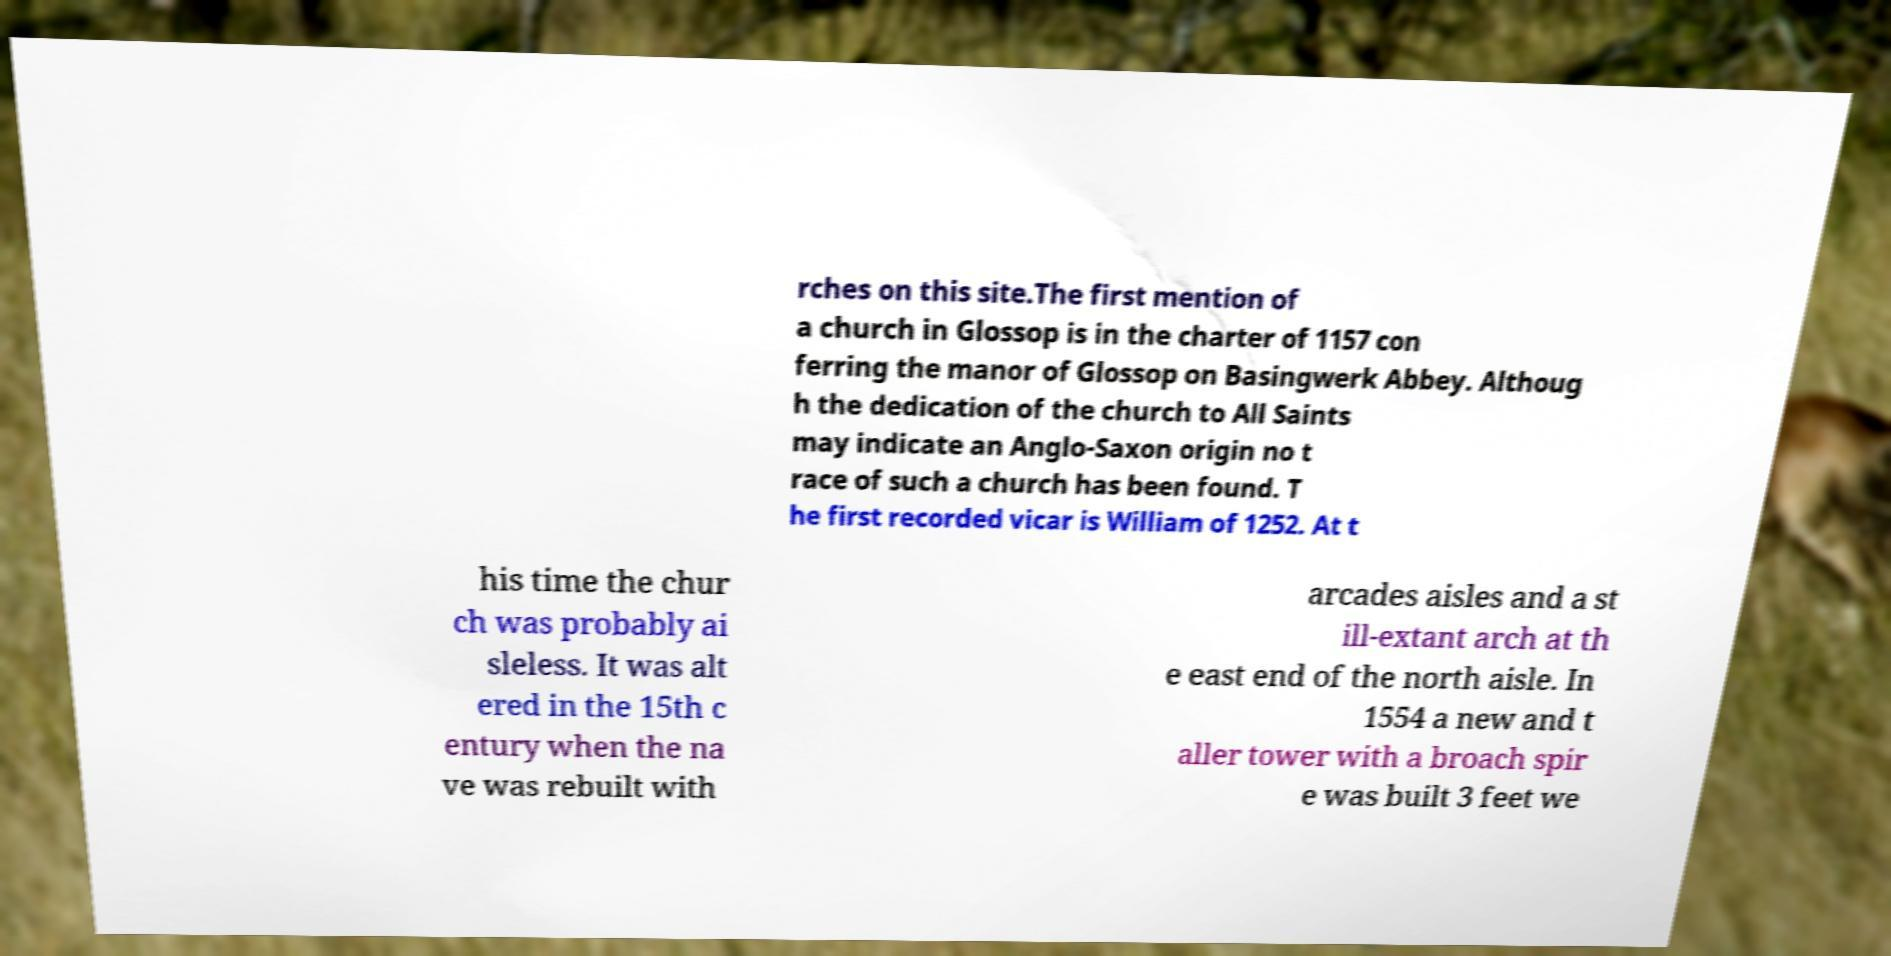Could you assist in decoding the text presented in this image and type it out clearly? rches on this site.The first mention of a church in Glossop is in the charter of 1157 con ferring the manor of Glossop on Basingwerk Abbey. Althoug h the dedication of the church to All Saints may indicate an Anglo-Saxon origin no t race of such a church has been found. T he first recorded vicar is William of 1252. At t his time the chur ch was probably ai sleless. It was alt ered in the 15th c entury when the na ve was rebuilt with arcades aisles and a st ill-extant arch at th e east end of the north aisle. In 1554 a new and t aller tower with a broach spir e was built 3 feet we 